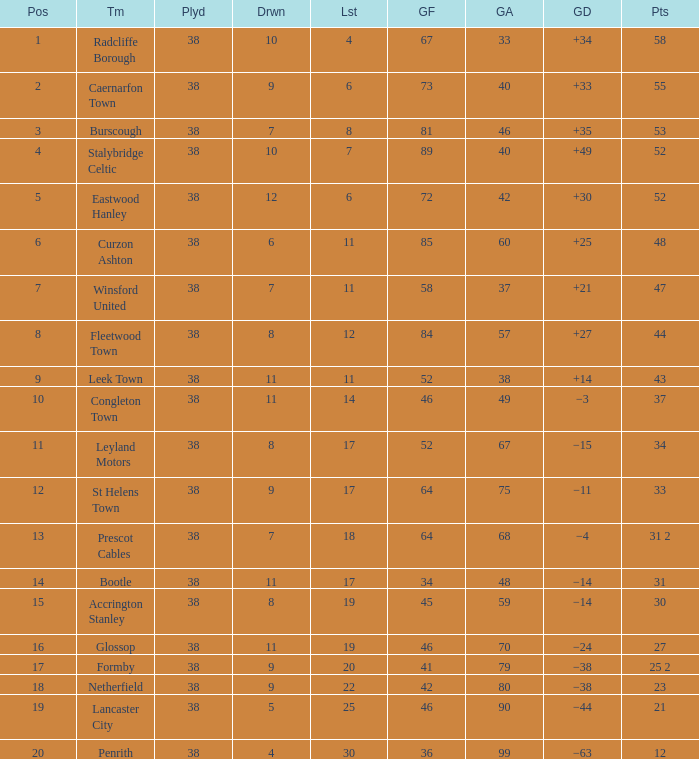WHAT IS THE POSITION WITH A LOST OF 6, FOR CAERNARFON TOWN? 2.0. 